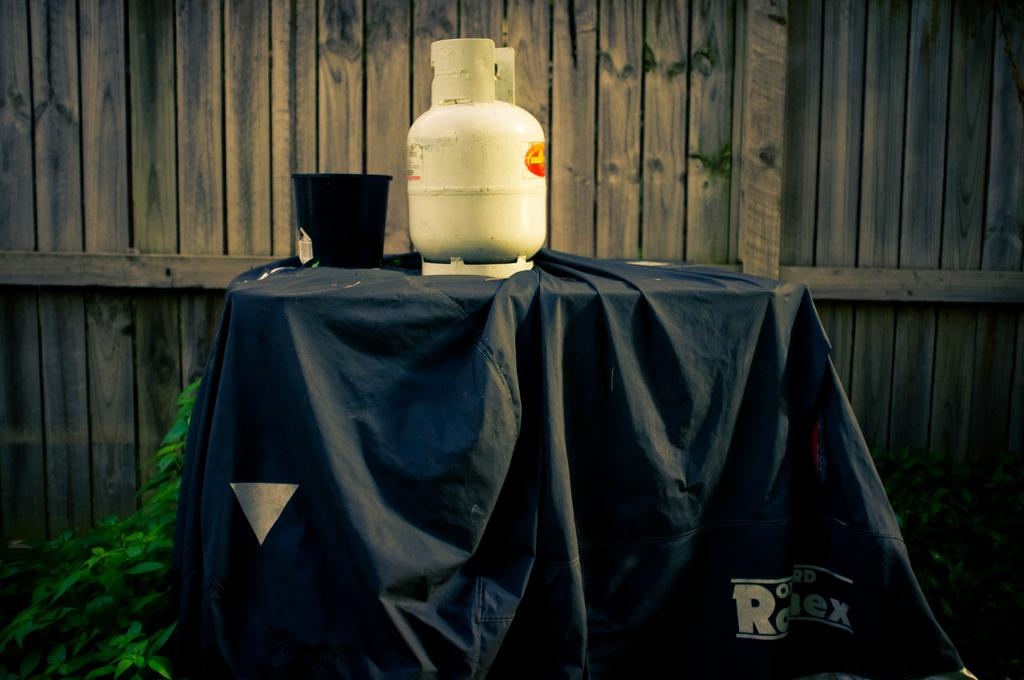What color is the cloth in the image? The cloth in the image is black. What objects are placed on the cloth? There is a cylinder and a bowl on the cloth. What can be seen in the background of the image? The background of the image includes wooden sticks. What type of animal can be seen in the cellar in the image? There is no cellar or animal present in the image. 